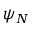Convert formula to latex. <formula><loc_0><loc_0><loc_500><loc_500>\psi _ { N }</formula> 